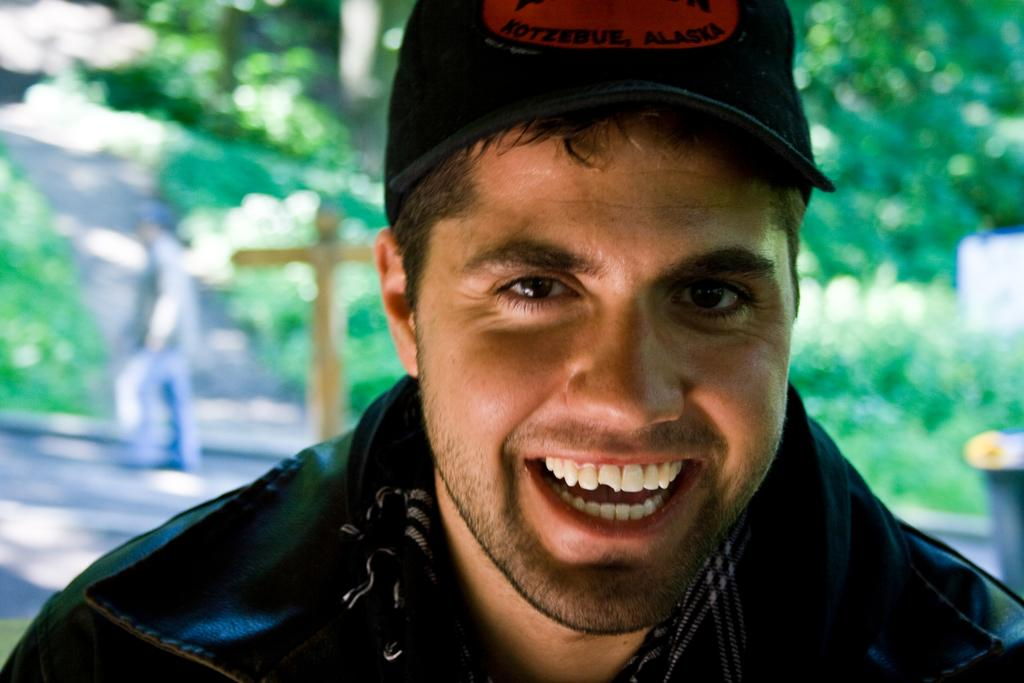What is the man in the image wearing? The man in the image is wearing a black jacket. What can be seen in the background of the image? There are trees visible in the background of the image. What is the person in the image doing? There is a person walking in the image. Can you describe any objects present in the image? There are objects present in the image, but their specific details are not mentioned in the provided facts. What type of business is the man in the image conducting? The provided facts do not mention any business-related activities, so it cannot be determined from the image. 